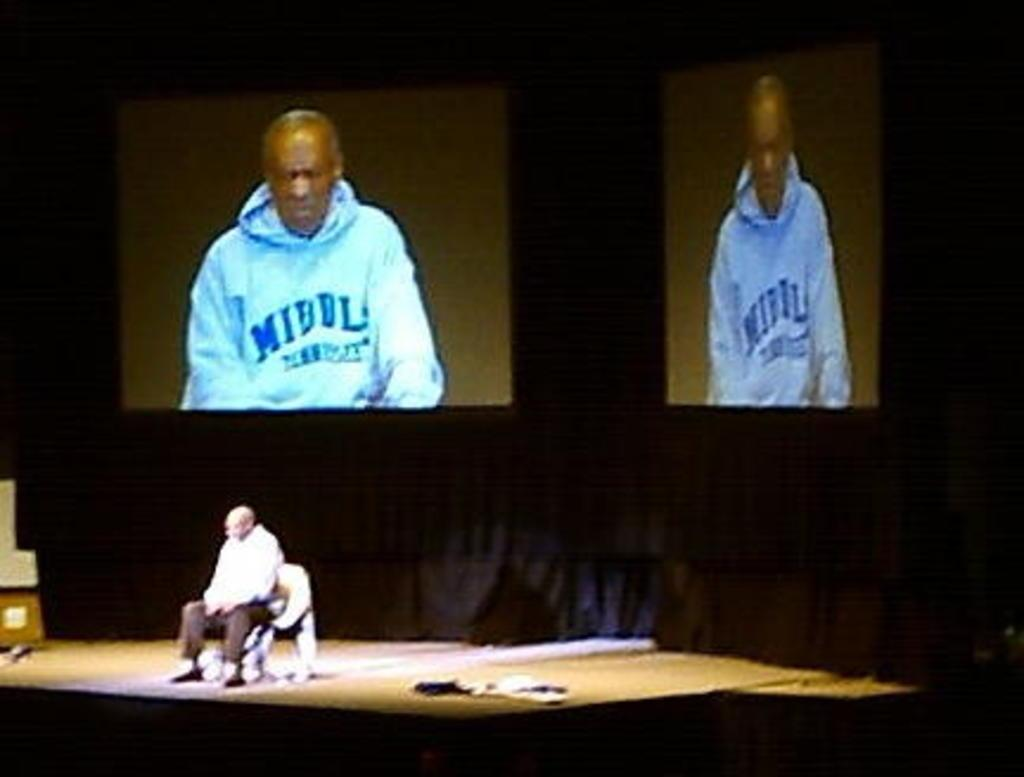What is the man in the image doing? The man is sitting on a chair in the image. What can be seen in the background of the image? There are two screens and a black curtain in the background of the image. Can you describe the content of one of the screens? Yes, there is a man visible on one of the screens. Where is the faucet located in the image? There is no faucet present in the image. What type of business is being conducted in the image? The image does not depict any business activities, so it cannot be determined from the image. 